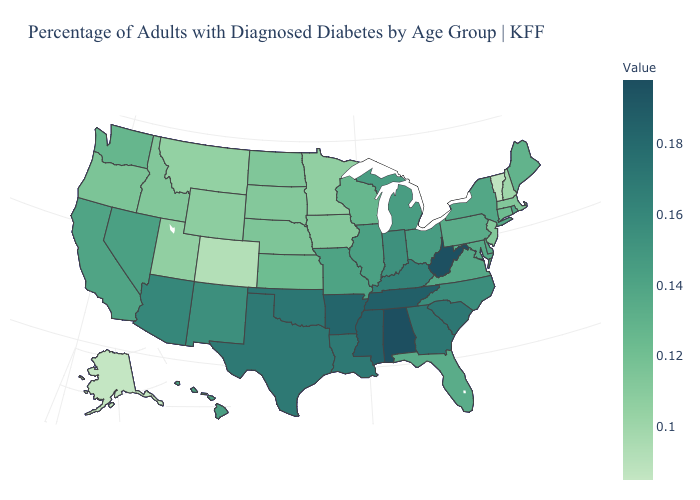Does Alabama have the highest value in the USA?
Keep it brief. Yes. Which states have the highest value in the USA?
Quick response, please. Alabama. Does the map have missing data?
Answer briefly. No. Which states hav the highest value in the Northeast?
Concise answer only. New York. Which states have the lowest value in the MidWest?
Concise answer only. Minnesota. 